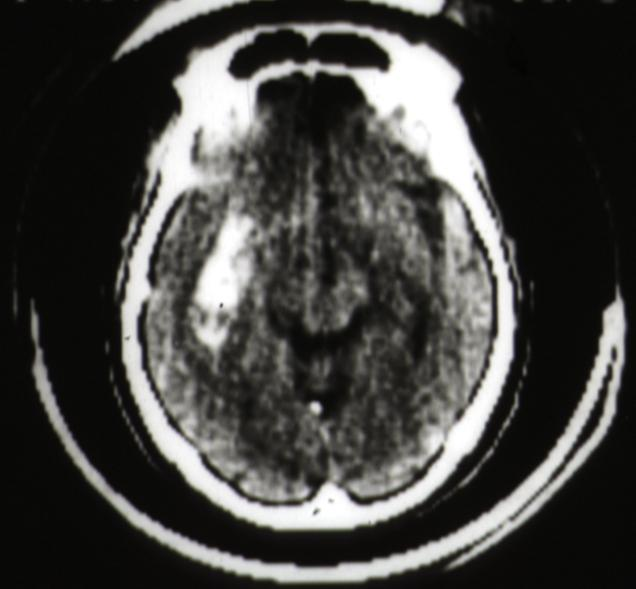what scan putamen hemorrhage?
Answer the question using a single word or phrase. Cat 